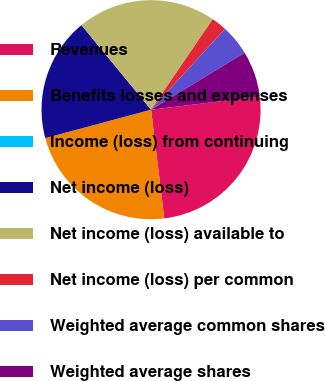Convert chart to OTSL. <chart><loc_0><loc_0><loc_500><loc_500><pie_chart><fcel>Revenues<fcel>Benefits losses and expenses<fcel>Income (loss) from continuing<fcel>Net income (loss)<fcel>Net income (loss) available to<fcel>Net income (loss) per common<fcel>Weighted average common shares<fcel>Weighted average shares<nl><fcel>24.99%<fcel>22.74%<fcel>0.01%<fcel>18.22%<fcel>20.48%<fcel>2.26%<fcel>4.52%<fcel>6.78%<nl></chart> 